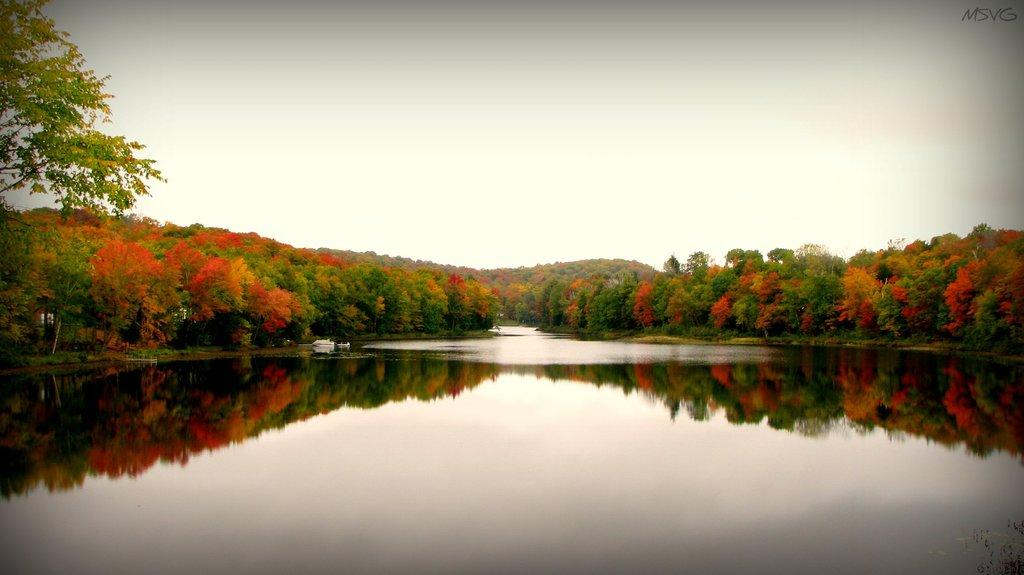What type of natural feature is at the bottom of the image? There is a river at the bottom of the image. What can be seen on the right side of the image? There are trees on the right side of the image. What can be seen on the left side of the image? There are trees on the left side of the image. What is visible at the top of the image? The sky is visible at the top of the image. Where is the fan located in the image? There is no fan present in the image. What type of transportation can be seen traveling along the river in the image? There is no transportation, such as a train, visible in the image. 